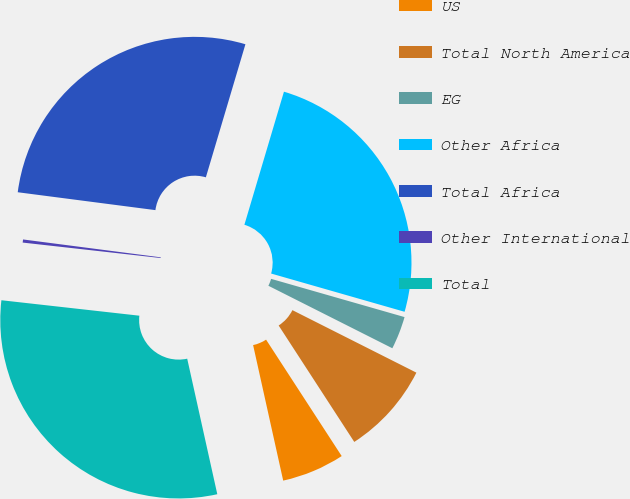<chart> <loc_0><loc_0><loc_500><loc_500><pie_chart><fcel>US<fcel>Total North America<fcel>EG<fcel>Other Africa<fcel>Total Africa<fcel>Other International<fcel>Total<nl><fcel>5.69%<fcel>8.4%<fcel>2.99%<fcel>24.84%<fcel>27.54%<fcel>0.28%<fcel>30.25%<nl></chart> 